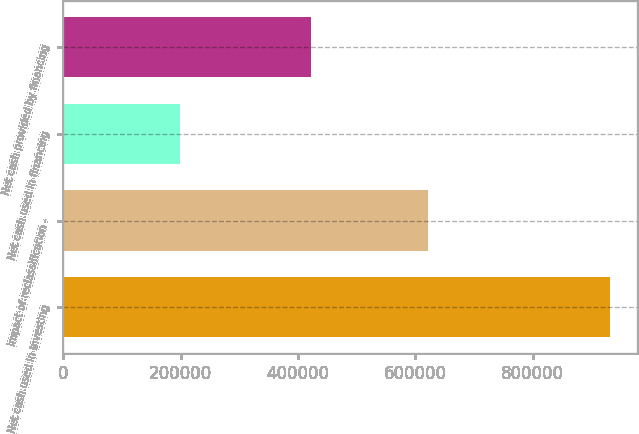Convert chart to OTSL. <chart><loc_0><loc_0><loc_500><loc_500><bar_chart><fcel>Net cash used in investing<fcel>Impact of reclassification -<fcel>Net cash used in financing<fcel>Net cash provided by financing<nl><fcel>930857<fcel>620807<fcel>199429<fcel>421378<nl></chart> 